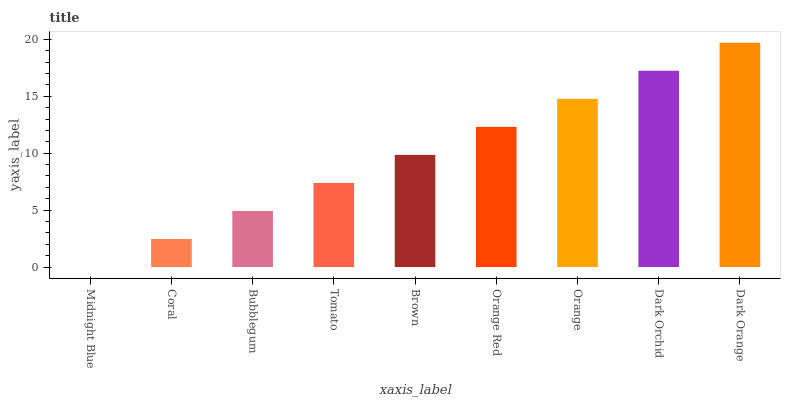Is Coral the minimum?
Answer yes or no. No. Is Coral the maximum?
Answer yes or no. No. Is Coral greater than Midnight Blue?
Answer yes or no. Yes. Is Midnight Blue less than Coral?
Answer yes or no. Yes. Is Midnight Blue greater than Coral?
Answer yes or no. No. Is Coral less than Midnight Blue?
Answer yes or no. No. Is Brown the high median?
Answer yes or no. Yes. Is Brown the low median?
Answer yes or no. Yes. Is Dark Orchid the high median?
Answer yes or no. No. Is Dark Orange the low median?
Answer yes or no. No. 